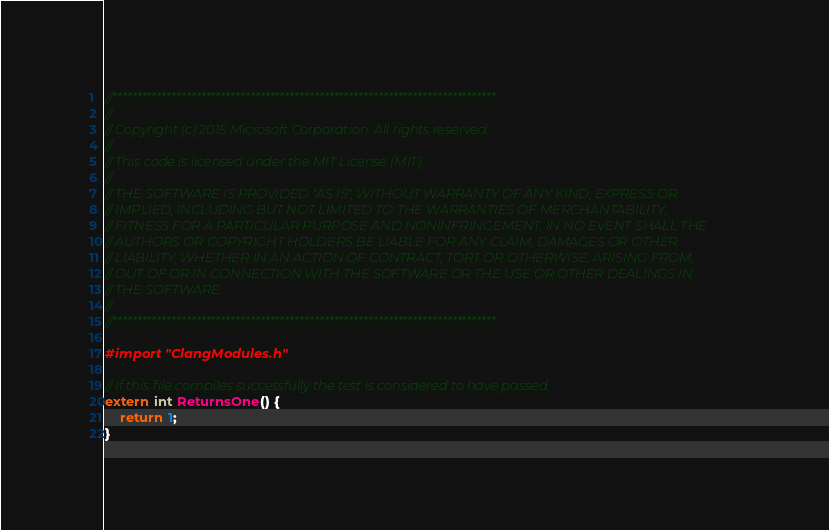<code> <loc_0><loc_0><loc_500><loc_500><_ObjectiveC_>//******************************************************************************
//
// Copyright (c) 2015 Microsoft Corporation. All rights reserved.
//
// This code is licensed under the MIT License (MIT).
//
// THE SOFTWARE IS PROVIDED "AS IS", WITHOUT WARRANTY OF ANY KIND, EXPRESS OR
// IMPLIED, INCLUDING BUT NOT LIMITED TO THE WARRANTIES OF MERCHANTABILITY,
// FITNESS FOR A PARTICULAR PURPOSE AND NONINFRINGEMENT. IN NO EVENT SHALL THE
// AUTHORS OR COPYRIGHT HOLDERS BE LIABLE FOR ANY CLAIM, DAMAGES OR OTHER
// LIABILITY, WHETHER IN AN ACTION OF CONTRACT, TORT OR OTHERWISE, ARISING FROM,
// OUT OF OR IN CONNECTION WITH THE SOFTWARE OR THE USE OR OTHER DEALINGS IN
// THE SOFTWARE.
//
//******************************************************************************

#import "ClangModules.h"

// If this file compiles successfully the test is considered to have passed
extern int ReturnsOne() {
    return 1;
}</code> 